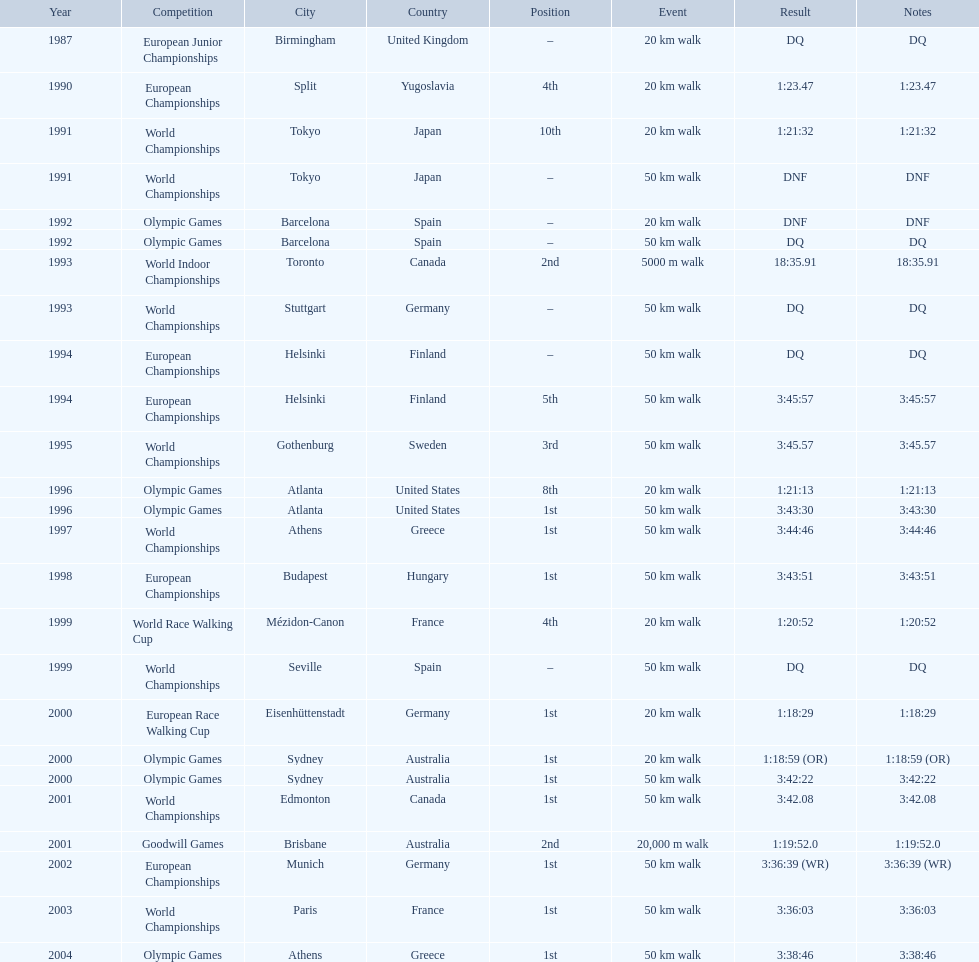In 1990 what position did robert korzeniowski place? 4th. In 1993 what was robert korzeniowski's place in the world indoor championships? 2nd. How long did the 50km walk in 2004 olympic cost? 3:38:46. Which of the competitions were 50 km walks? World Championships, Olympic Games, World Championships, European Championships, European Championships, World Championships, Olympic Games, World Championships, European Championships, World Championships, Olympic Games, World Championships, European Championships, World Championships, Olympic Games. Of these, which took place during or after the year 2000? Olympic Games, World Championships, European Championships, World Championships, Olympic Games. From these, which took place in athens, greece? Olympic Games. What was the time to finish for this competition? 3:38:46. 